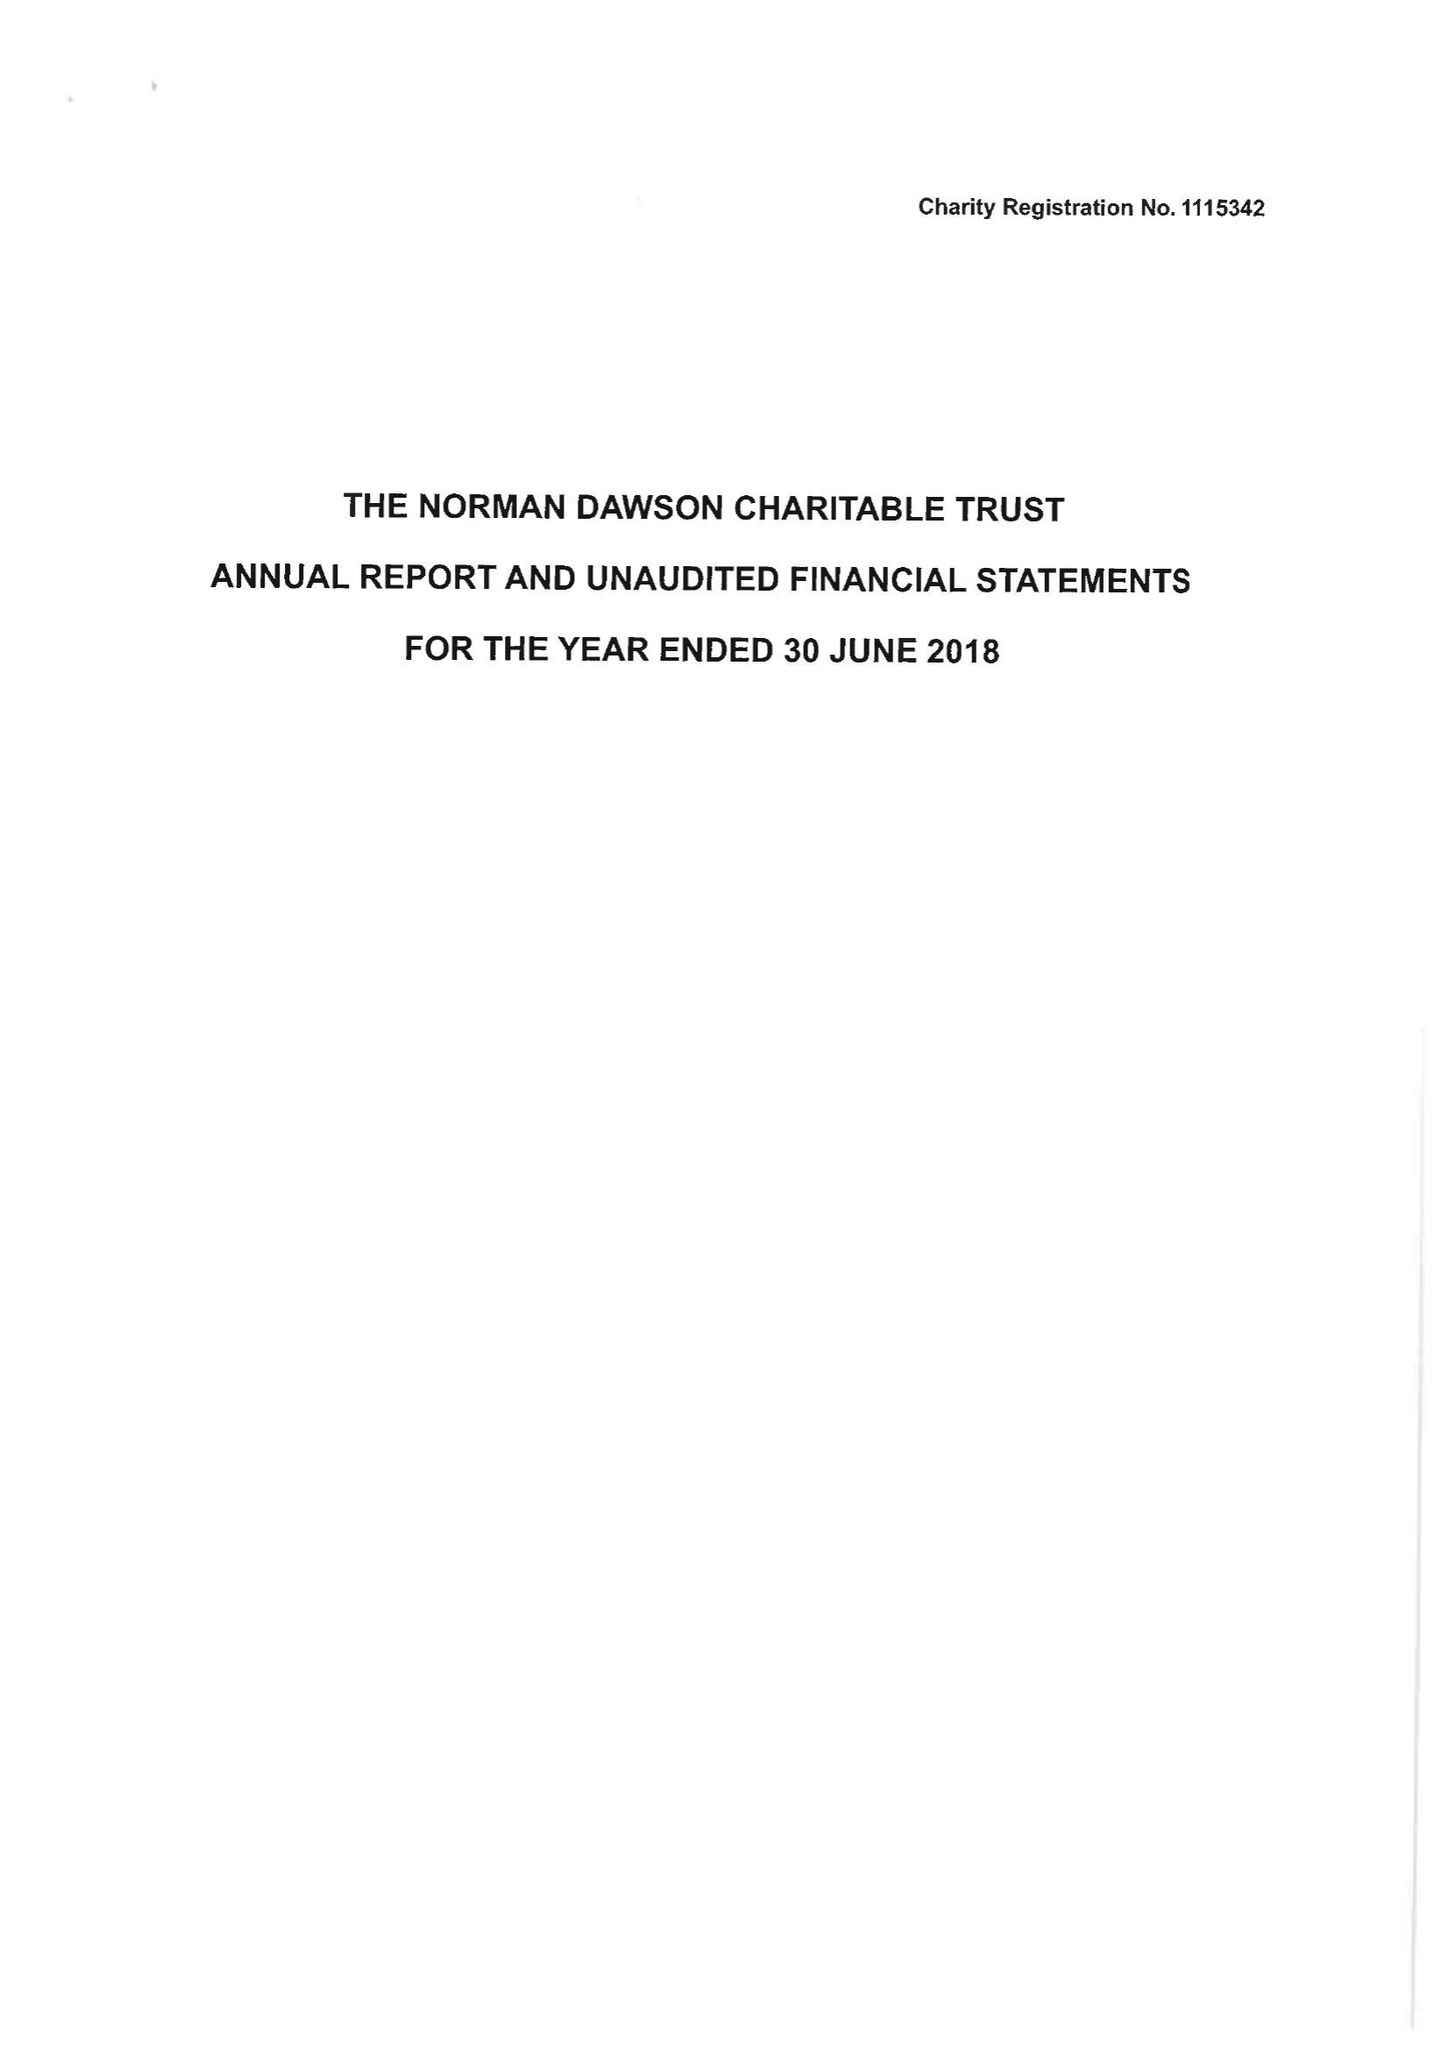What is the value for the spending_annually_in_british_pounds?
Answer the question using a single word or phrase. 48622.00 